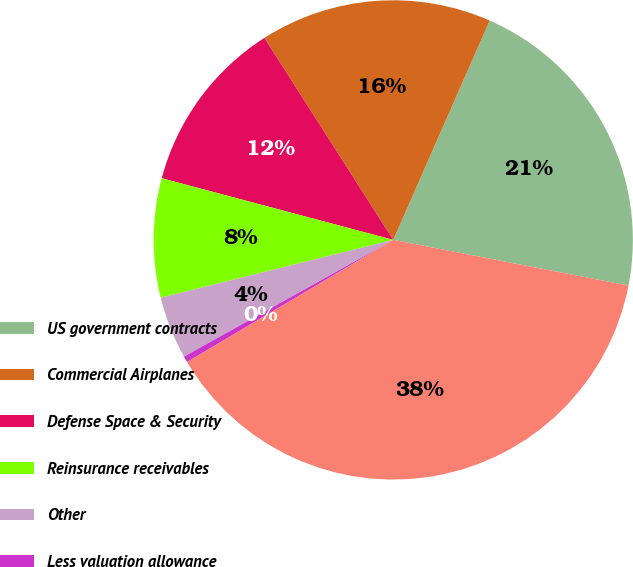Convert chart. <chart><loc_0><loc_0><loc_500><loc_500><pie_chart><fcel>US government contracts<fcel>Commercial Airplanes<fcel>Defense Space & Security<fcel>Reinsurance receivables<fcel>Other<fcel>Less valuation allowance<fcel>Total<nl><fcel>21.46%<fcel>15.63%<fcel>11.82%<fcel>8.02%<fcel>4.22%<fcel>0.41%<fcel>38.44%<nl></chart> 